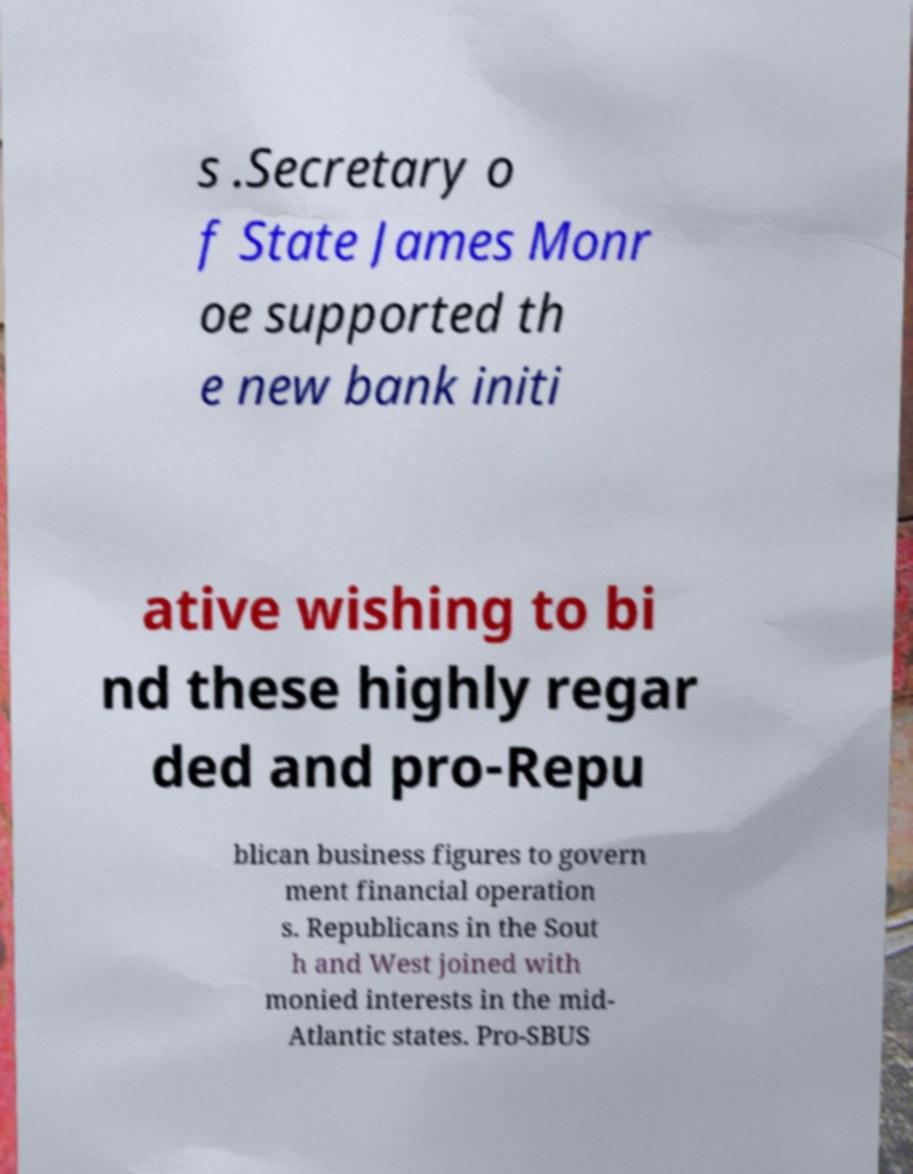Can you read and provide the text displayed in the image?This photo seems to have some interesting text. Can you extract and type it out for me? s .Secretary o f State James Monr oe supported th e new bank initi ative wishing to bi nd these highly regar ded and pro-Repu blican business figures to govern ment financial operation s. Republicans in the Sout h and West joined with monied interests in the mid- Atlantic states. Pro-SBUS 